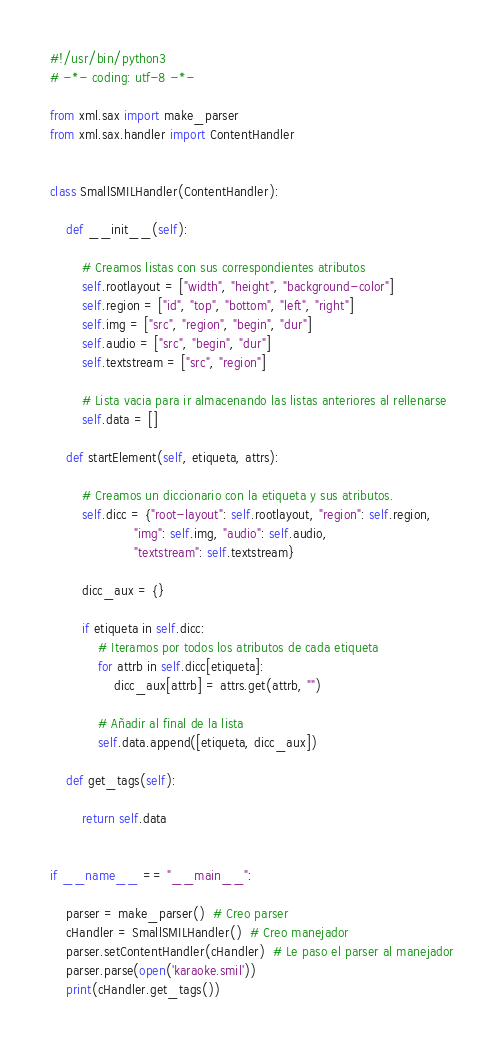<code> <loc_0><loc_0><loc_500><loc_500><_Python_>#!/usr/bin/python3
# -*- coding: utf-8 -*-

from xml.sax import make_parser
from xml.sax.handler import ContentHandler


class SmallSMILHandler(ContentHandler):

    def __init__(self):

        # Creamos listas con sus correspondientes atributos
        self.rootlayout = ["width", "height", "background-color"]
        self.region = ["id", "top", "bottom", "left", "right"]
        self.img = ["src", "region", "begin", "dur"]
        self.audio = ["src", "begin", "dur"]
        self.textstream = ["src", "region"]

        # Lista vacia para ir almacenando las listas anteriores al rellenarse
        self.data = []

    def startElement(self, etiqueta, attrs):

        # Creamos un diccionario con la etiqueta y sus atributos.
        self.dicc = {"root-layout": self.rootlayout, "region": self.region,
                     "img": self.img, "audio": self.audio,
                     "textstream": self.textstream}

        dicc_aux = {}

        if etiqueta in self.dicc:
            # Iteramos por todos los atributos de cada etiqueta
            for attrb in self.dicc[etiqueta]:
                dicc_aux[attrb] = attrs.get(attrb, "")

            # Añadir al final de la lista
            self.data.append([etiqueta, dicc_aux])

    def get_tags(self):

        return self.data


if __name__ == "__main__":

    parser = make_parser()  # Creo parser
    cHandler = SmallSMILHandler()  # Creo manejador
    parser.setContentHandler(cHandler)  # Le paso el parser al manejador
    parser.parse(open('karaoke.smil'))
    print(cHandler.get_tags())
</code> 